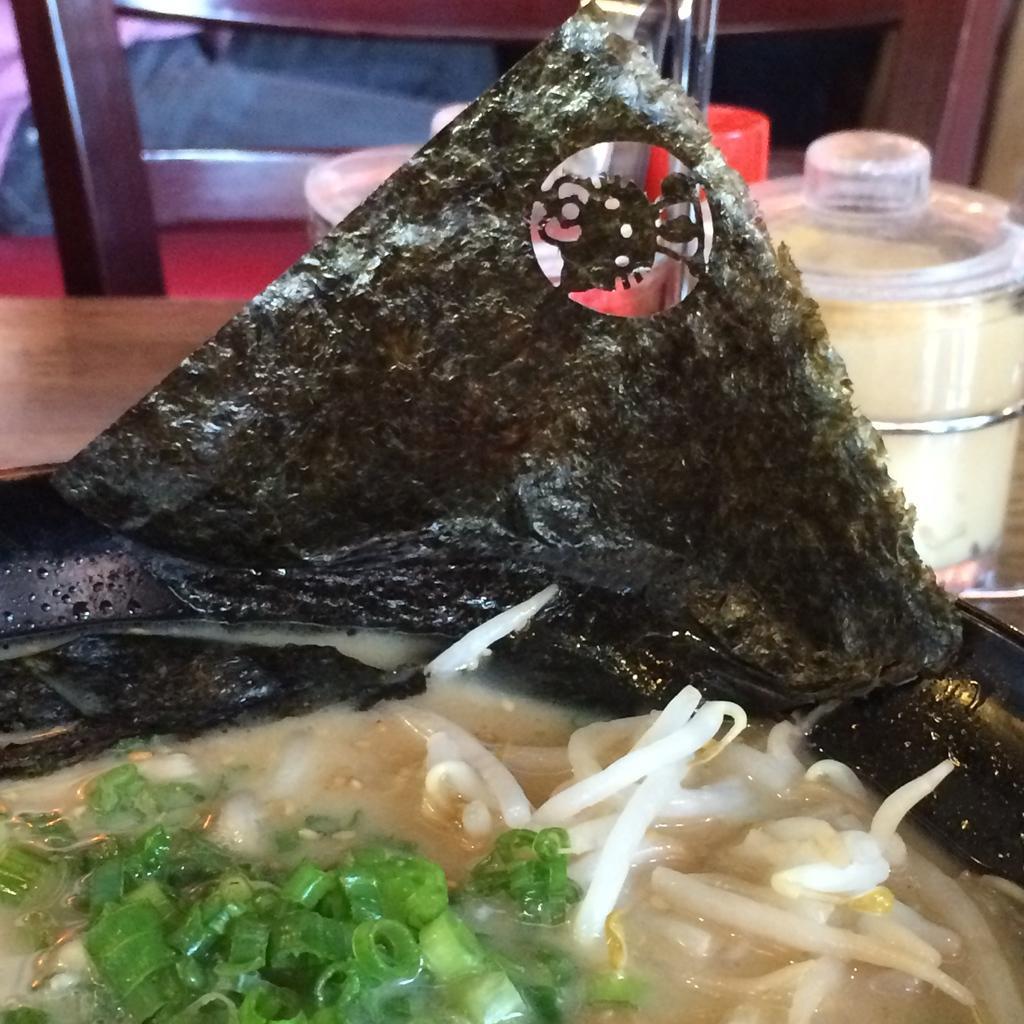How would you summarize this image in a sentence or two? In this picture we can see food, and we can find few bowls on the table. 